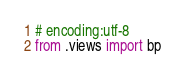Convert code to text. <code><loc_0><loc_0><loc_500><loc_500><_Python_># encoding:utf-8
from .views import bp</code> 